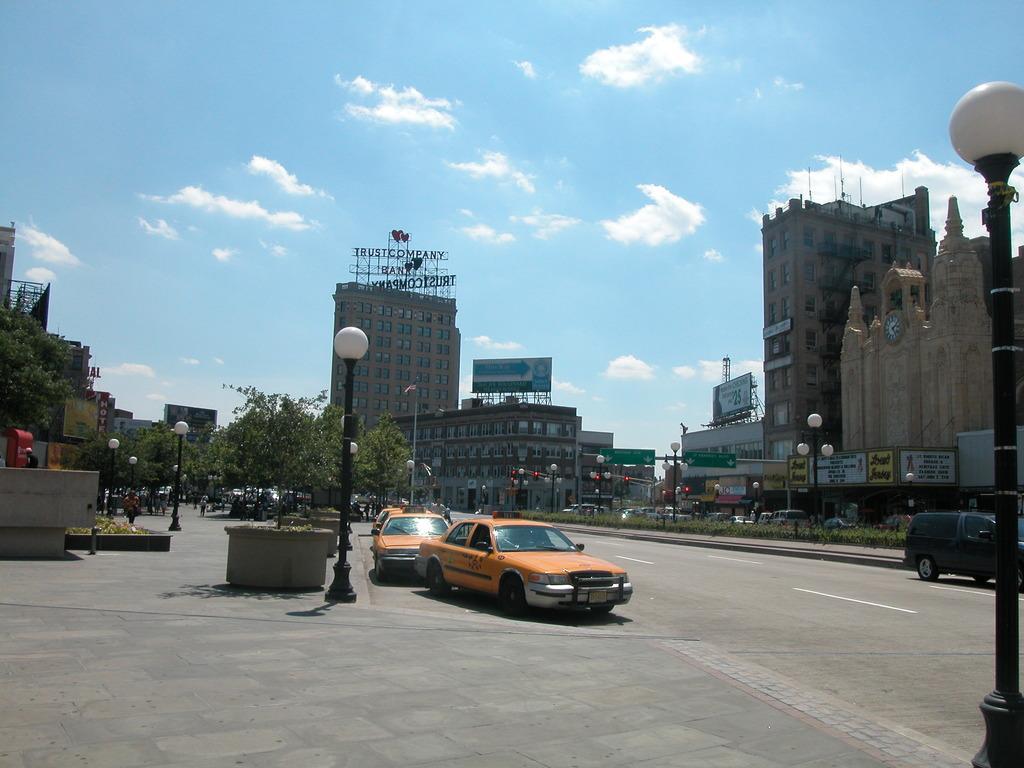Could you give a brief overview of what you see in this image? In this image I see the road on which there are number of vehicles and I see the light poles. In the background I see number of buildings and the trees and I see the traffic signals over here and I see boards on which there is something written and I see the sky which is clear. 